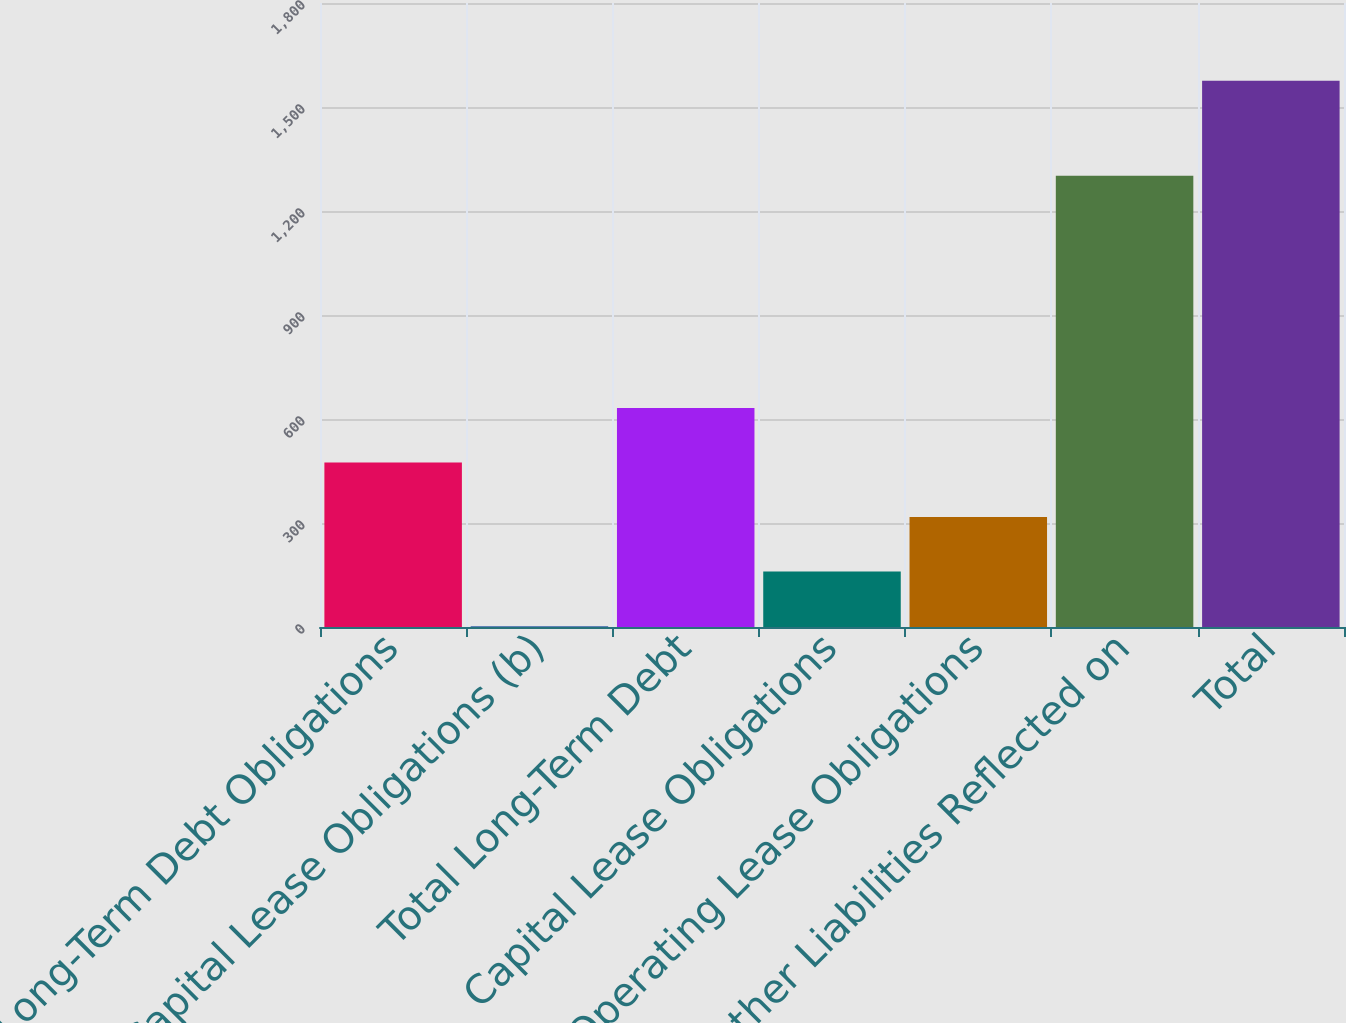Convert chart. <chart><loc_0><loc_0><loc_500><loc_500><bar_chart><fcel>Long-Term Debt Obligations<fcel>Capital Lease Obligations (b)<fcel>Total Long-Term Debt<fcel>Capital Lease Obligations<fcel>Operating Lease Obligations<fcel>Other Liabilities Reflected on<fcel>Total<nl><fcel>474.47<fcel>2.6<fcel>631.76<fcel>159.89<fcel>317.18<fcel>1301.8<fcel>1575.5<nl></chart> 